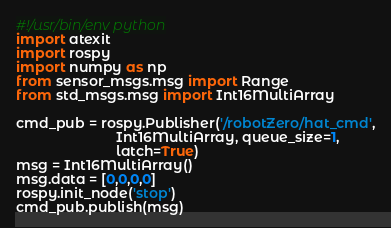Convert code to text. <code><loc_0><loc_0><loc_500><loc_500><_Python_>#!/usr/bin/env python
import atexit
import rospy
import numpy as np
from sensor_msgs.msg import Range
from std_msgs.msg import Int16MultiArray

cmd_pub = rospy.Publisher('/robotZero/hat_cmd',
                          Int16MultiArray, queue_size=1,
                          latch=True)
msg = Int16MultiArray()
msg.data = [0,0,0,0]
rospy.init_node('stop')
cmd_pub.publish(msg)
</code> 